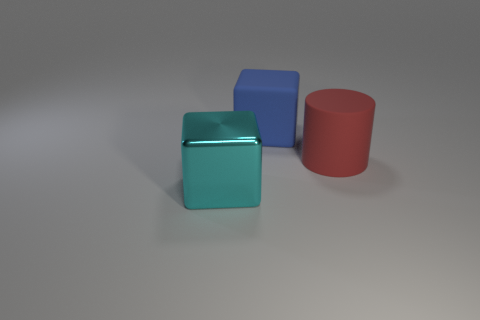What material is the big object that is left of the large blue rubber thing?
Keep it short and to the point. Metal. Is there a gray shiny object of the same shape as the large cyan object?
Offer a terse response. No. What number of cyan shiny things are the same shape as the large blue rubber thing?
Ensure brevity in your answer.  1. There is a big object that is to the left of the rubber object behind the large red rubber cylinder; what is its shape?
Make the answer very short. Cube. Is the number of metallic cubes in front of the cyan cube the same as the number of cyan blocks?
Give a very brief answer. No. What material is the big block in front of the large matte object on the right side of the cube that is behind the large shiny cube?
Give a very brief answer. Metal. Is there a cyan metal cube of the same size as the red rubber thing?
Ensure brevity in your answer.  Yes. What is the shape of the big red rubber object?
Provide a succinct answer. Cylinder. What number of cylinders are either big red things or blue objects?
Give a very brief answer. 1. Are there an equal number of blue rubber objects that are in front of the big cyan metallic object and cyan metal things right of the big blue matte cube?
Make the answer very short. Yes. 